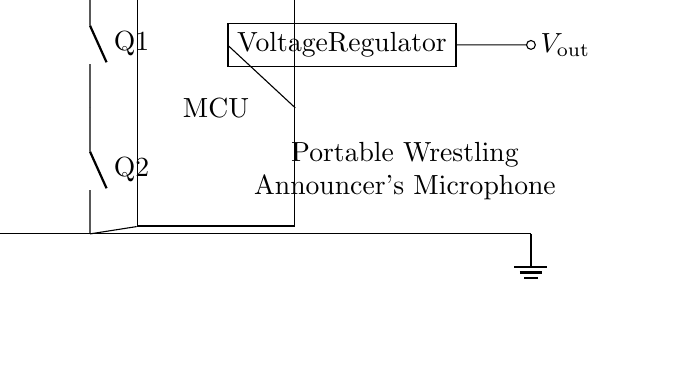What is the voltage source in this circuit? The voltage source is represented by the component labeled as "V_bat" in the circuit diagram. This is the battery providing power to the entire circuit.
Answer: V_bat How many nos components are present in the circuit? There are two nos components labeled Q1 and Q2. Each is connected in series to provide overcurrent protection for the circuit.
Answer: 2 What is the function of the voltage regulator in this circuit? The voltage regulator (labeled as Voltage Regulator) stabilizes the output voltage to a specific level required by the microcontroller and the microphone. It ensures consistent power supply despite variations in the battery voltage.
Answer: Stabilization What are the two inputs to the microcontroller? The microcontroller receives power from two lines: one from the top connection of the battery management circuit and the other from the ground level connection. These ensure proper circuit functionality.
Answer: V_bat and ground Which component protects the circuit from excess current? The two nos components, Q1 and Q2, serve the purpose of protection against excess current, ensuring that if the current exceeds safe limits, the circuit is interrupted.
Answer: Q1 and Q2 What is the output load of this battery management circuit? The output load of the circuit is connected to a portable wrestling announcer's microphone, which is powered through the output from the voltage regulator.
Answer: Microphone What is the orientation of the battery in the circuit? The battery is oriented vertically in the circuit diagram, indicating its positive and negative terminals, with the positive terminal at the top and negative at the bottom.
Answer: Vertical 